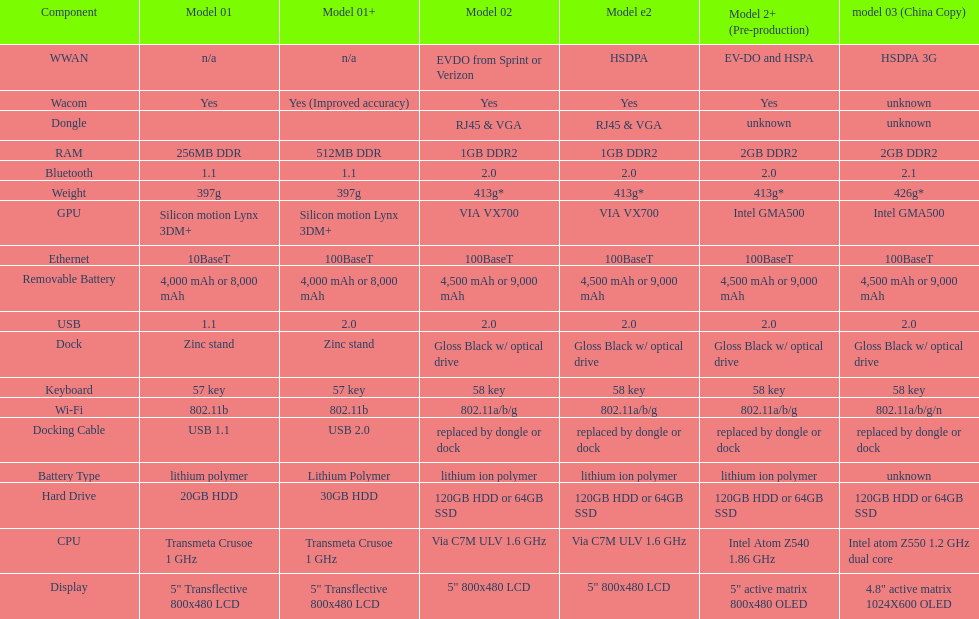Which model weighs the most, according to the table? Model 03 (china copy). 